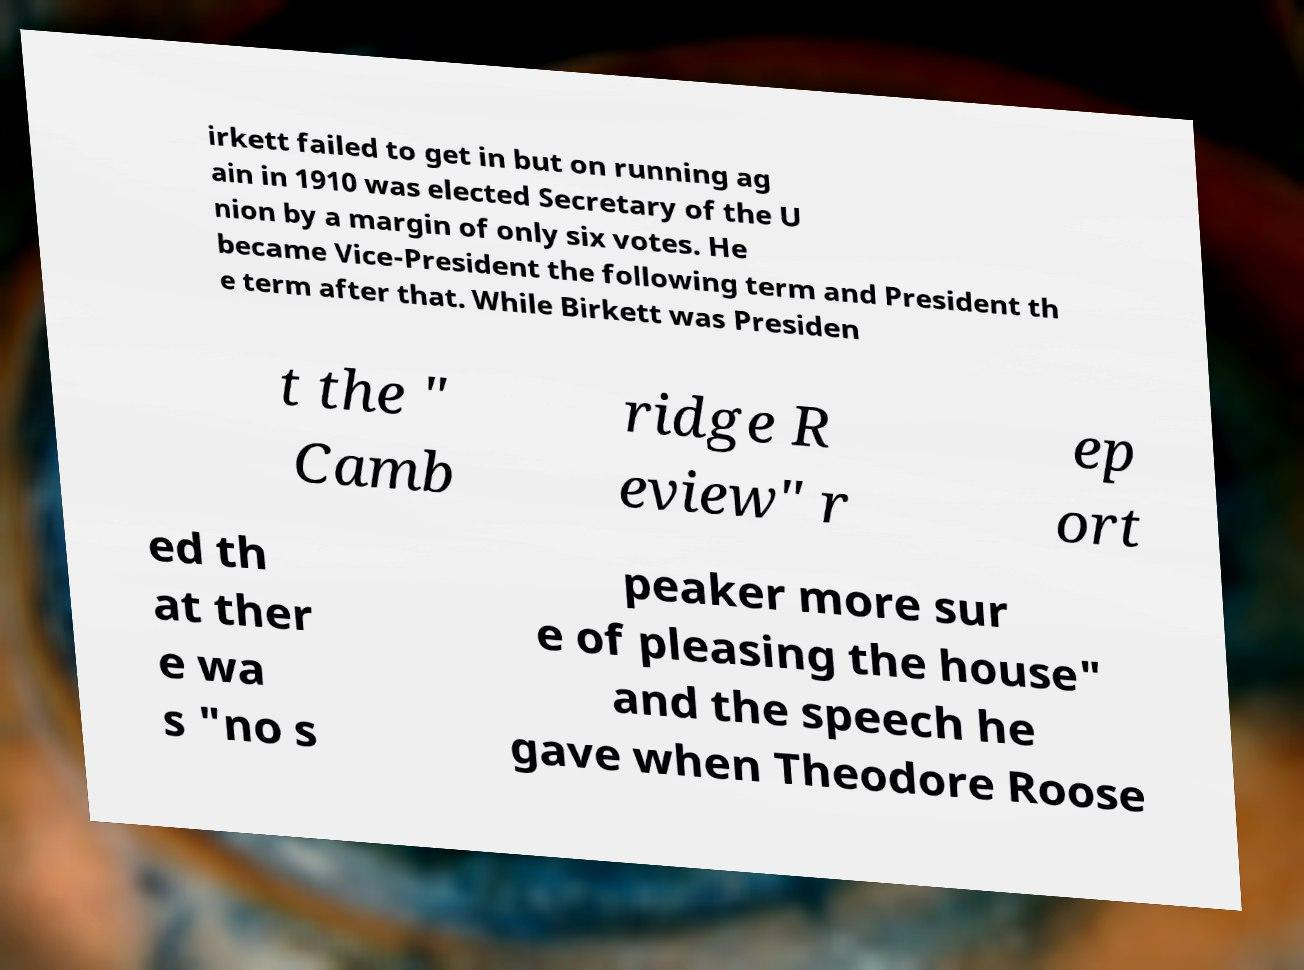Please read and relay the text visible in this image. What does it say? irkett failed to get in but on running ag ain in 1910 was elected Secretary of the U nion by a margin of only six votes. He became Vice-President the following term and President th e term after that. While Birkett was Presiden t the " Camb ridge R eview" r ep ort ed th at ther e wa s "no s peaker more sur e of pleasing the house" and the speech he gave when Theodore Roose 